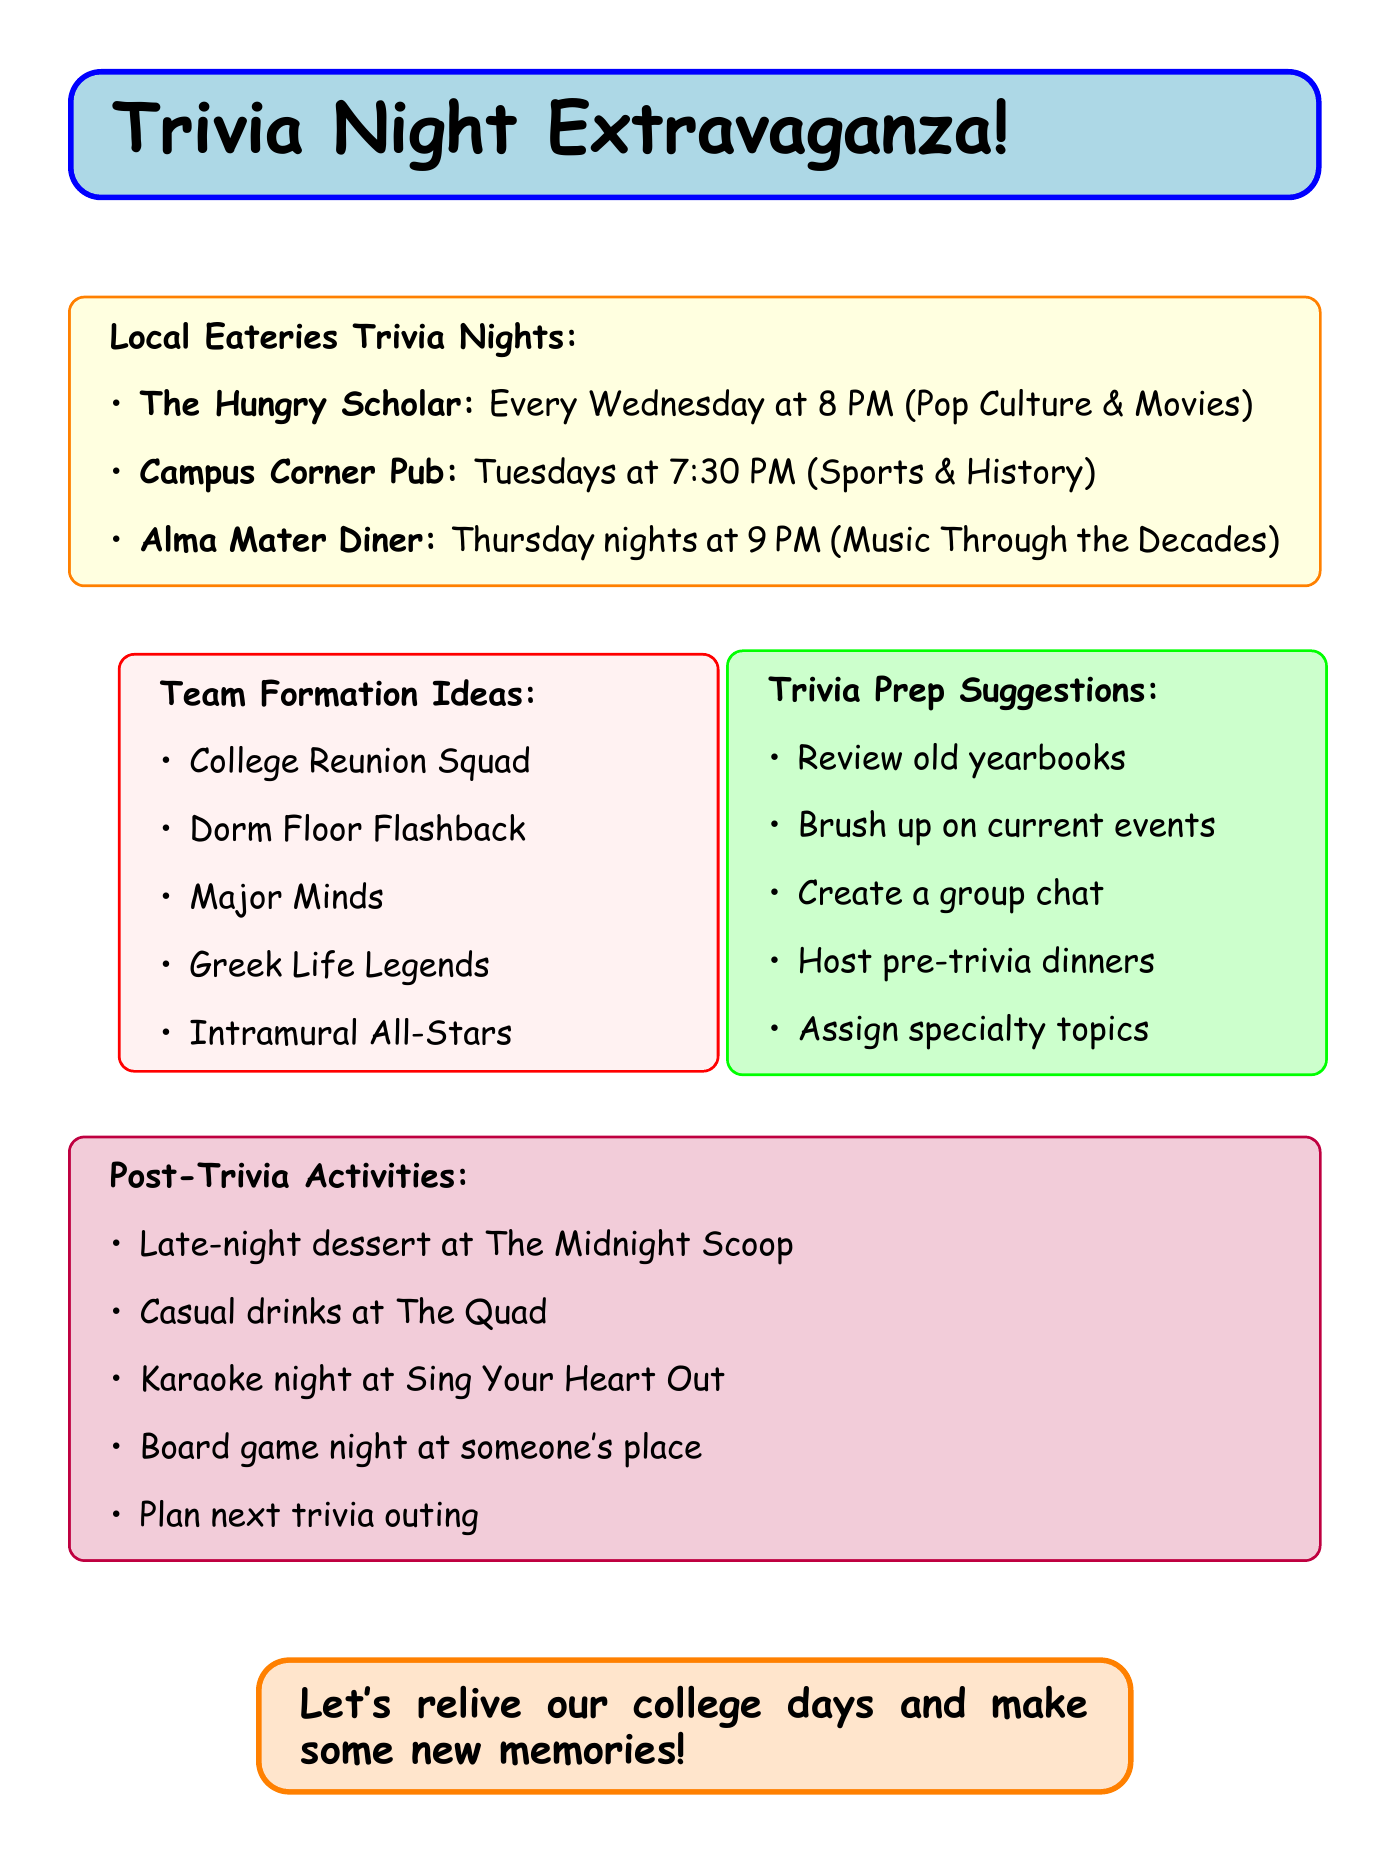What night is trivia hosted at The Hungry Scholar? The question is asking for the specific trivia night for a particular eatery mentioned in the document. It states that The Hungry Scholar has trivia every Wednesday at 8 PM.
Answer: Every Wednesday at 8 PM What is the theme for trivia night at Campus Corner Pub? This question requires recalling the theme associated with the trivia night provided in the document for a specific eatery. The theme for Campus Corner Pub is Sports & History.
Answer: Sports & History How many people can form a team at The Hungry Scholar? This question asks for specific team formation information provided in the document regarding the size limit for teams at a particular location. It states that teams can consist of up to 6 people.
Answer: Up to 6 people What is one post-trivia activity mentioned in the document? This question requires recalling any activity listed under post-trivia activities. The document includes several activities, such as a late-night dessert run to The Midnight Scoop.
Answer: Late-night dessert run to The Midnight Scoop What team formation idea relates to college major? This question is seeking a specific team idea mentioned in the document that connects with participants’ academic backgrounds. The answer is "Major Minds."
Answer: Major Minds What day does trivia night occur at Alma Mater Diner? This question asks for the specific day trivia is hosted at a certain diner mentioned in the document. Alma Mater Diner hosts trivia on Thursday nights.
Answer: Thursday nights How should teams be formed at Campus Corner Pub? The question inquires about the team formation method used at a specific local pub mentioned in the document. It states that teams are assigned randomly.
Answer: Random team assignment What is a suggestion for preparing for trivia night? This question requires recalling one of the prep suggestions listed in the document. An example of a suggestion is to review old yearbooks.
Answer: Review old yearbooks 